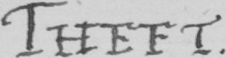Transcribe the text shown in this historical manuscript line. THEFT 